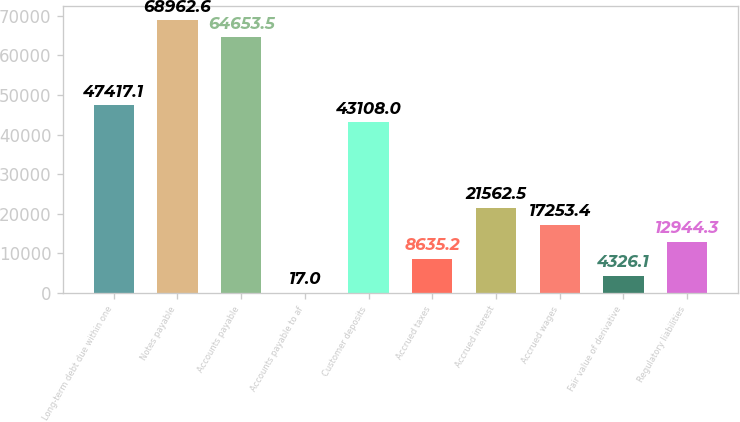Convert chart. <chart><loc_0><loc_0><loc_500><loc_500><bar_chart><fcel>Long-term debt due within one<fcel>Notes payable<fcel>Accounts payable<fcel>Accounts payable to af<fcel>Customer deposits<fcel>Accrued taxes<fcel>Accrued interest<fcel>Accrued wages<fcel>Fair value of derivative<fcel>Regulatory liabilities<nl><fcel>47417.1<fcel>68962.6<fcel>64653.5<fcel>17<fcel>43108<fcel>8635.2<fcel>21562.5<fcel>17253.4<fcel>4326.1<fcel>12944.3<nl></chart> 